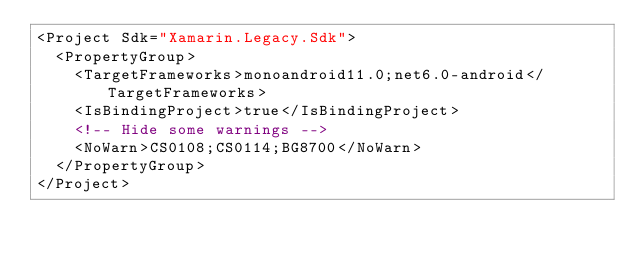Convert code to text. <code><loc_0><loc_0><loc_500><loc_500><_XML_><Project Sdk="Xamarin.Legacy.Sdk">
  <PropertyGroup>
    <TargetFrameworks>monoandroid11.0;net6.0-android</TargetFrameworks>
    <IsBindingProject>true</IsBindingProject>
    <!-- Hide some warnings -->
    <NoWarn>CS0108;CS0114;BG8700</NoWarn>
  </PropertyGroup>
</Project></code> 